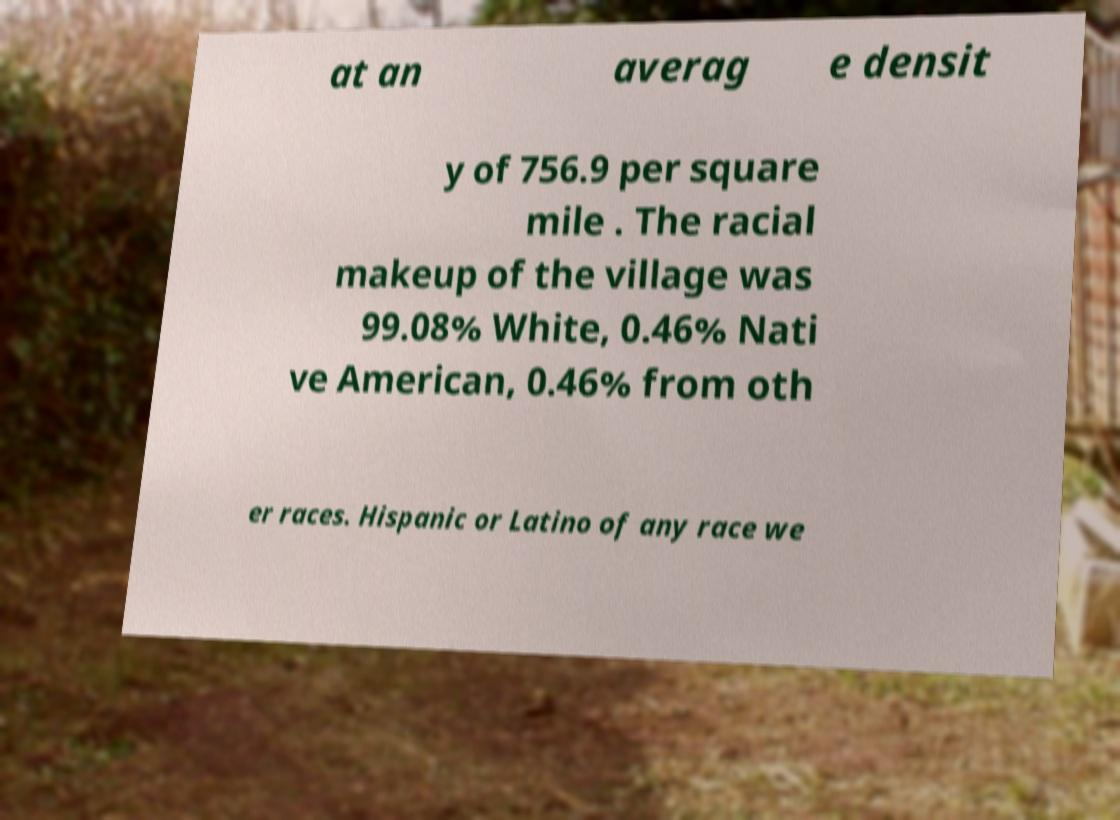Can you read and provide the text displayed in the image?This photo seems to have some interesting text. Can you extract and type it out for me? at an averag e densit y of 756.9 per square mile . The racial makeup of the village was 99.08% White, 0.46% Nati ve American, 0.46% from oth er races. Hispanic or Latino of any race we 